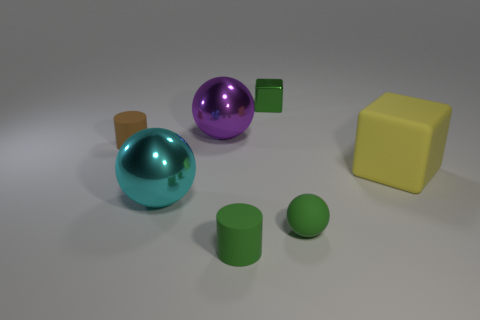How do the shadows in the image inform us about the light source position? The shadows are cast toward the left and slightly forward, indicating that the light source is positioned to the right and possibly above the objects. This suggests a diagonal angle of illumination that helps create a sense of depth and dimension in the image. 